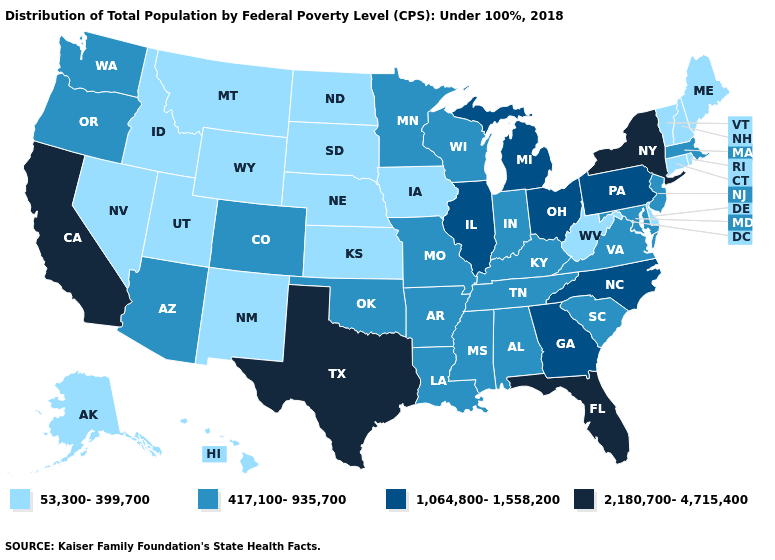Does the map have missing data?
Give a very brief answer. No. What is the value of Alaska?
Short answer required. 53,300-399,700. What is the value of Pennsylvania?
Keep it brief. 1,064,800-1,558,200. What is the value of Georgia?
Give a very brief answer. 1,064,800-1,558,200. What is the value of Alaska?
Quick response, please. 53,300-399,700. Name the states that have a value in the range 417,100-935,700?
Write a very short answer. Alabama, Arizona, Arkansas, Colorado, Indiana, Kentucky, Louisiana, Maryland, Massachusetts, Minnesota, Mississippi, Missouri, New Jersey, Oklahoma, Oregon, South Carolina, Tennessee, Virginia, Washington, Wisconsin. Name the states that have a value in the range 417,100-935,700?
Quick response, please. Alabama, Arizona, Arkansas, Colorado, Indiana, Kentucky, Louisiana, Maryland, Massachusetts, Minnesota, Mississippi, Missouri, New Jersey, Oklahoma, Oregon, South Carolina, Tennessee, Virginia, Washington, Wisconsin. Name the states that have a value in the range 1,064,800-1,558,200?
Concise answer only. Georgia, Illinois, Michigan, North Carolina, Ohio, Pennsylvania. Does Massachusetts have the highest value in the USA?
Answer briefly. No. Does Colorado have the lowest value in the West?
Quick response, please. No. How many symbols are there in the legend?
Answer briefly. 4. What is the value of Illinois?
Answer briefly. 1,064,800-1,558,200. Among the states that border Indiana , which have the lowest value?
Write a very short answer. Kentucky. Which states have the lowest value in the MidWest?
Short answer required. Iowa, Kansas, Nebraska, North Dakota, South Dakota. Does the first symbol in the legend represent the smallest category?
Short answer required. Yes. 